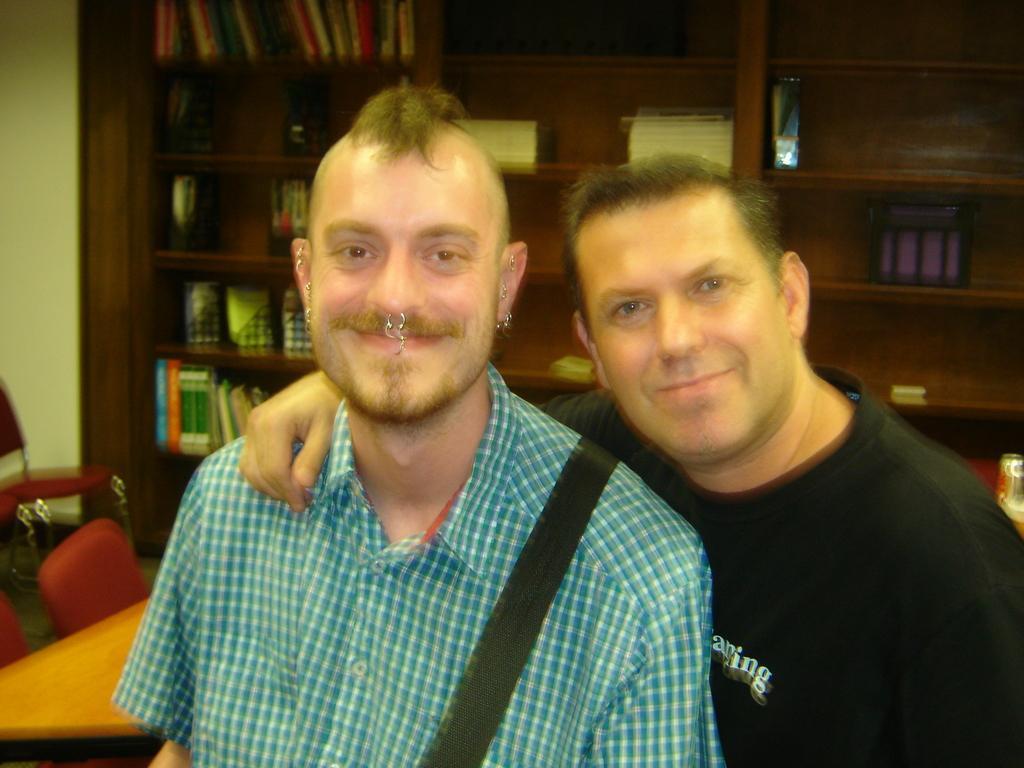In one or two sentences, can you explain what this image depicts? In this picture we can see two men smiling. There are few chairs and a table on the left side. We can see a bottle on the right side. There are few books and other objects in the shelves. 